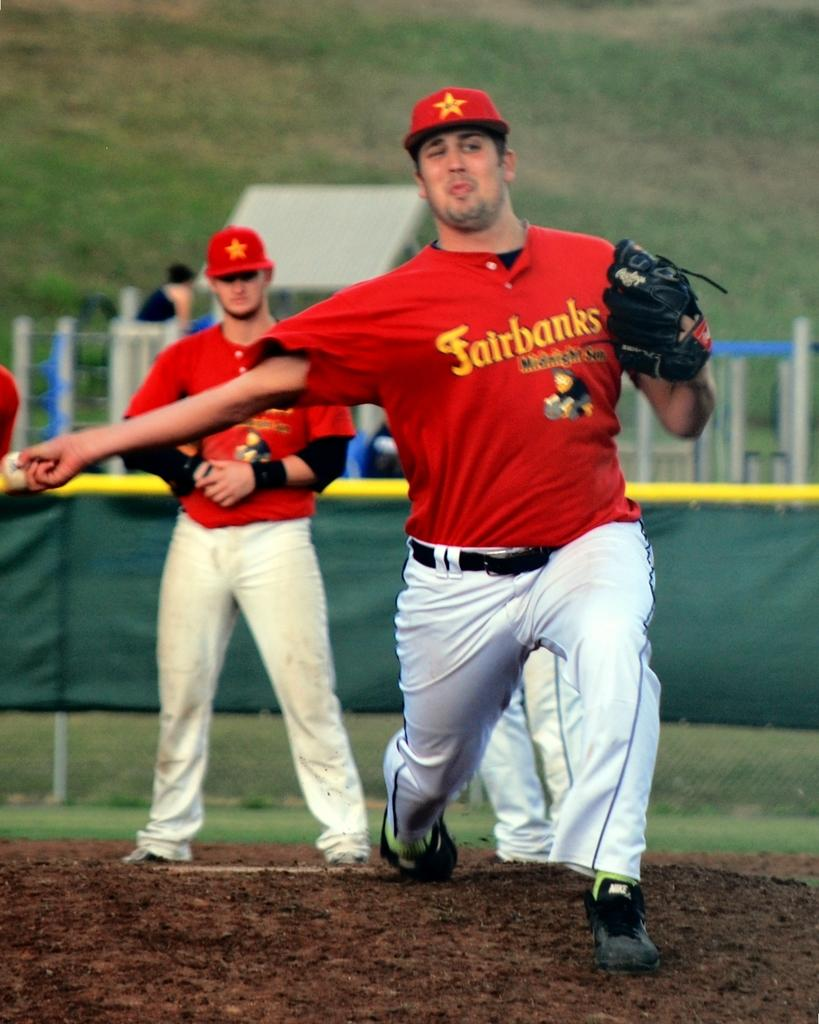<image>
Create a compact narrative representing the image presented. Two men playing what looks like baseball wearing red Fairbanks shirts 